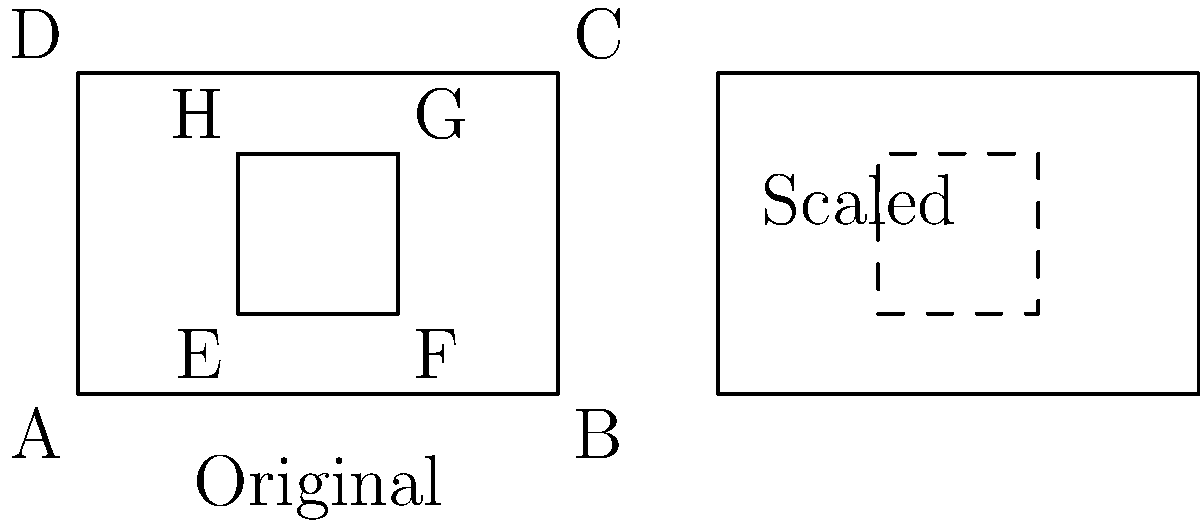As a small business owner, you want to optimize your store layout. Your current store is represented by the rectangle ABCD, with dimensions 6 units by 4 units. The inner rectangle EFGH represents the current product display area. You plan to expand your store by scaling it up by a factor of 1.5. What will be the area of the new product display space after scaling? Let's approach this step-by-step:

1) First, let's calculate the current area of the product display space (EFGH):
   Width of EFGH = 4 units
   Height of EFGH = 2 units
   Area of EFGH = 4 * 2 = 8 square units

2) Now, we need to scale this area by a factor of 1.5. However, we need to be careful here. When we scale a two-dimensional figure, the area increases by the square of the scale factor.

3) The new scale factor for area = $1.5^2 = 2.25$

4) Therefore, the new area of the product display space will be:
   New Area = Original Area * $(1.5)^2$
             = 8 * 2.25
             = 18 square units

5) We can verify this by calculating the new dimensions:
   New width = 4 * 1.5 = 6 units
   New height = 2 * 1.5 = 3 units
   New area = 6 * 3 = 18 square units

Thus, after scaling, the new product display area will be 18 square units.
Answer: 18 square units 